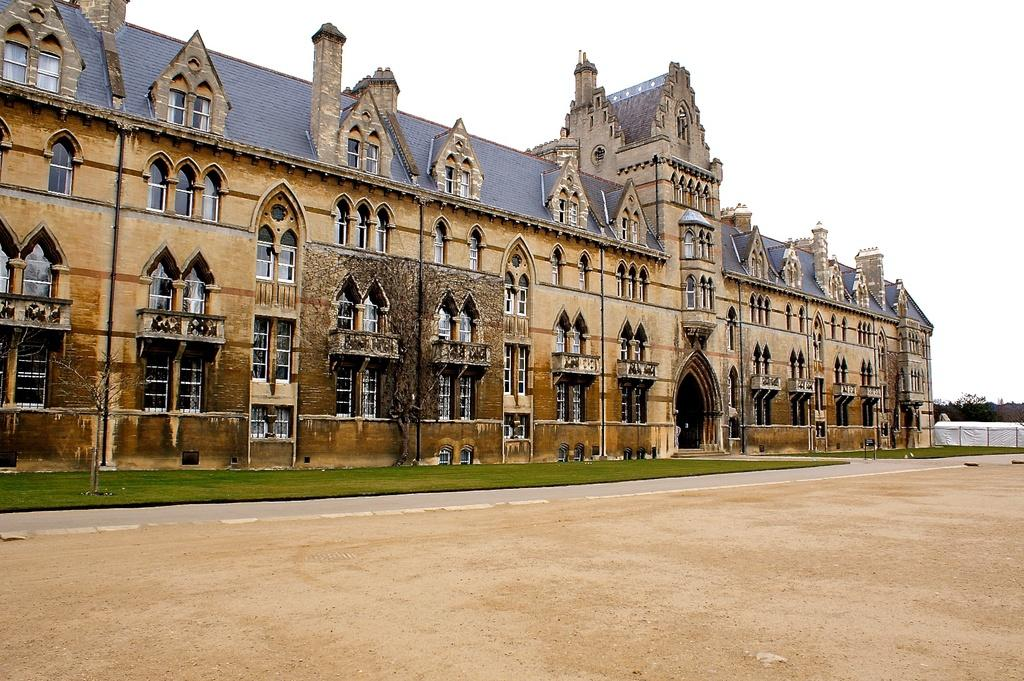What can be seen in the center of the image? The sky is visible in the center of the image. What type of structure is present in the image? There is a building in the image. What feature of the building is mentioned in the facts? The building has windows. What type of barrier is present in the image? There are fences in the image. What type of vegetation is present in the image? Grass is present in the image. What color is mentioned for a structure in the image? There is a white color structure in the image. How many other objects are mentioned in the facts? There are a few other objects in the image. How many elbows can be seen in the image? There are no elbows visible in the image. What statement is being made by the objects in the image? The objects in the image are not making any statements; they are simply present. How many cats are visible in the image? There are no cats present in the image. 